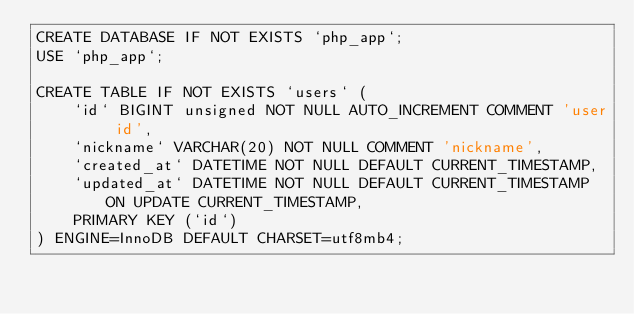Convert code to text. <code><loc_0><loc_0><loc_500><loc_500><_SQL_>CREATE DATABASE IF NOT EXISTS `php_app`;
USE `php_app`;

CREATE TABLE IF NOT EXISTS `users` (
    `id` BIGINT unsigned NOT NULL AUTO_INCREMENT COMMENT 'user id',
    `nickname` VARCHAR(20) NOT NULL COMMENT 'nickname',
    `created_at` DATETIME NOT NULL DEFAULT CURRENT_TIMESTAMP,
    `updated_at` DATETIME NOT NULL DEFAULT CURRENT_TIMESTAMP ON UPDATE CURRENT_TIMESTAMP,
    PRIMARY KEY (`id`)
) ENGINE=InnoDB DEFAULT CHARSET=utf8mb4;</code> 